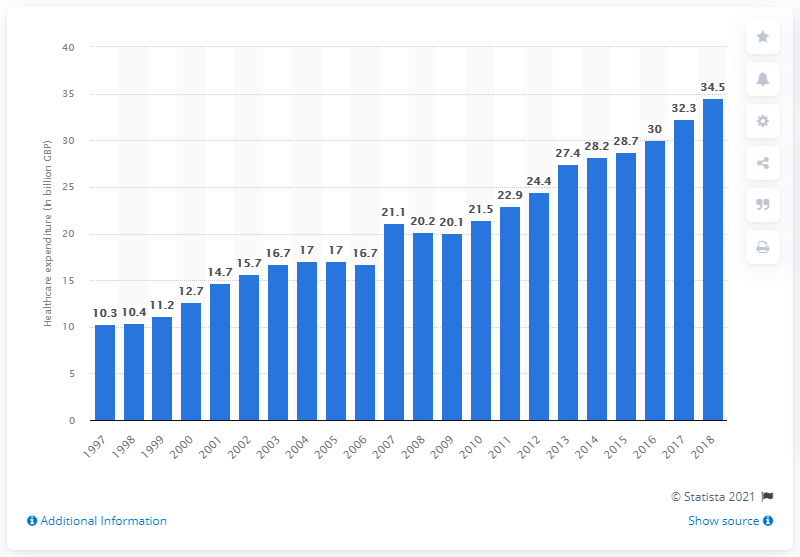Outline some significant characteristics in this image. In 2018, the private sector spent a total of 34.5 billion dollars. 